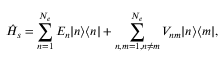<formula> <loc_0><loc_0><loc_500><loc_500>\hat { H } _ { s } = \sum _ { n = 1 } ^ { N _ { e } } E _ { n } | n \rangle \langle n | + \sum _ { n , m = 1 , n \neq m } ^ { N _ { e } } V _ { n m } | n \rangle \langle m | ,</formula> 